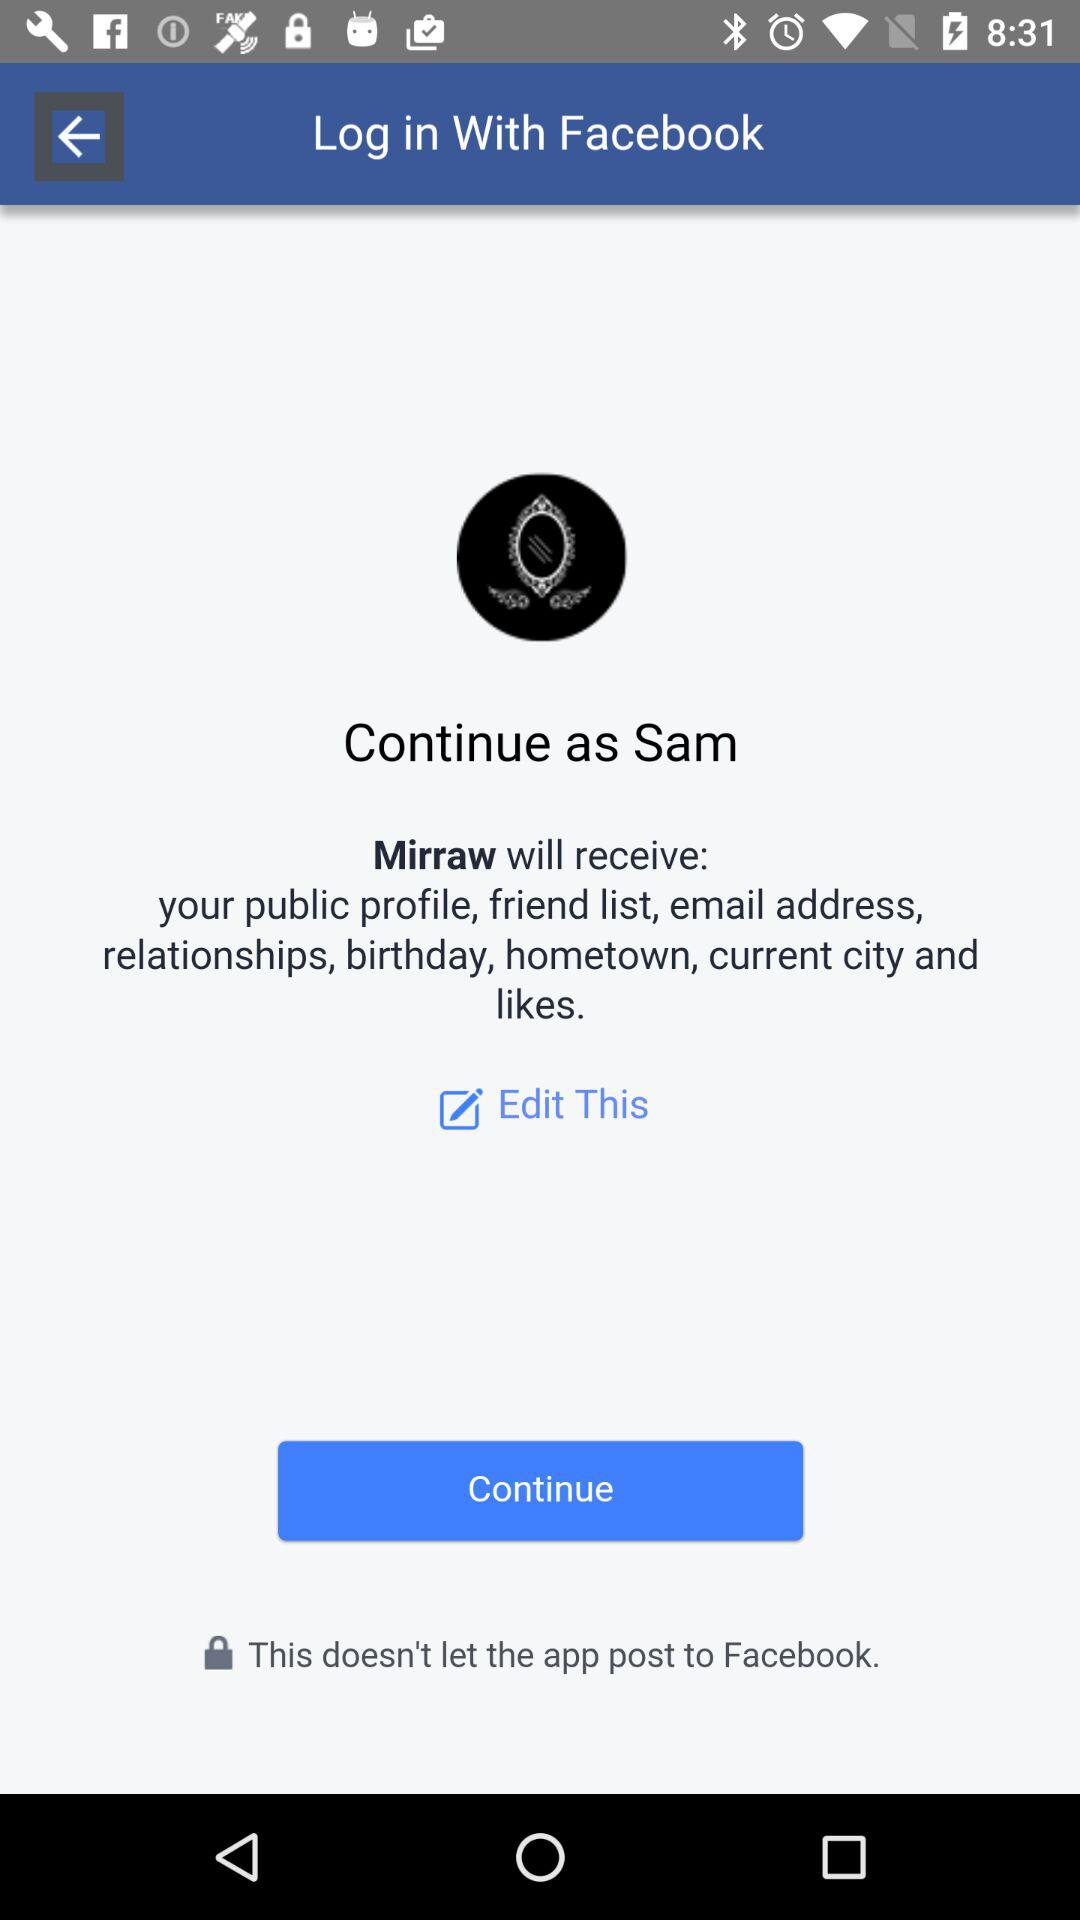What is the user name? The user name is Sam. 